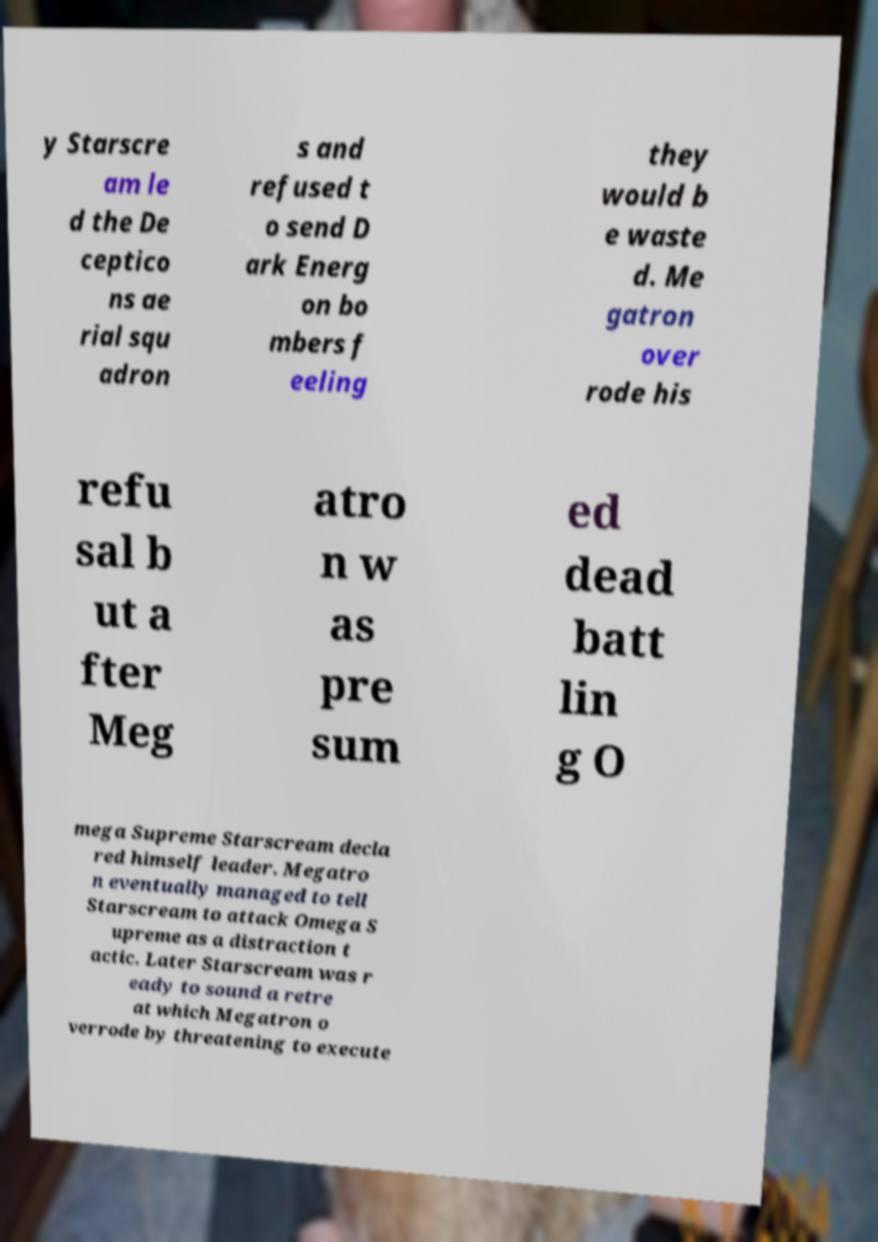Could you assist in decoding the text presented in this image and type it out clearly? y Starscre am le d the De ceptico ns ae rial squ adron s and refused t o send D ark Energ on bo mbers f eeling they would b e waste d. Me gatron over rode his refu sal b ut a fter Meg atro n w as pre sum ed dead batt lin g O mega Supreme Starscream decla red himself leader. Megatro n eventually managed to tell Starscream to attack Omega S upreme as a distraction t actic. Later Starscream was r eady to sound a retre at which Megatron o verrode by threatening to execute 